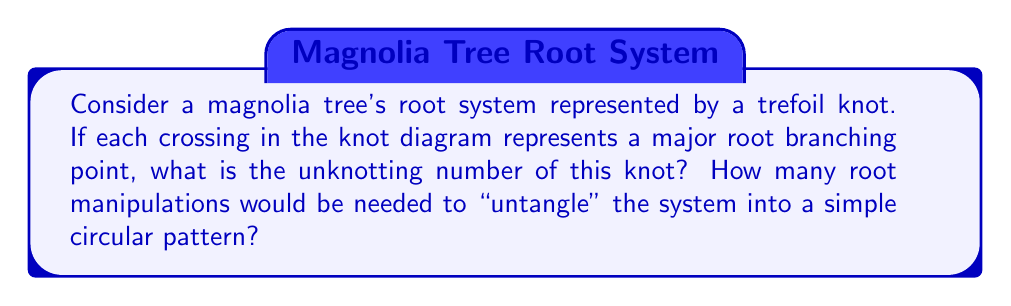Show me your answer to this math problem. To solve this problem, let's approach it step-by-step:

1. The trefoil knot is one of the simplest non-trivial knots in knot theory. It has three crossings in its standard diagram.

2. The unknotting number of a knot is the minimum number of crossing changes required to transform the knot into an unknot (a simple loop with no crossings).

3. For the trefoil knot, it's known that the unknotting number is 1. This means we need to change only one crossing to transform it into an unknot.

4. Mathematically, we can represent this as:

   $$u(K_{trefoil}) = 1$$

   where $u(K)$ denotes the unknotting number of knot $K$.

5. In the context of magnolia roots:
   - Each crossing represents a major root branching point.
   - The unknotting number represents the minimum number of root manipulations needed to "untangle" the system.
   - "Untangling" in this context means transforming the root system into a simple circular pattern (analogous to an unknot).

6. Therefore, only one root manipulation (changing one branching point) would be needed to transform the trefoil-like root system into a simple circular pattern.

[asy]
import geometry;

path p = (0,0)..(-1,1)..(1,1)..(0,0)..(-1,-1)..(1,-1)..cycle;
draw(p, linewidth(1));
dot((0,0.67));
dot((0.67,-0.33));
dot((-0.67,-0.33));
label("1", (0,0.8), N);
label("2", (0.8,-0.4), E);
label("3", (-0.8,-0.4), W);
[/asy]

The diagram above shows a trefoil knot with numbered crossings. Changing any one of these crossings would unknot the trefoil.
Answer: 1 